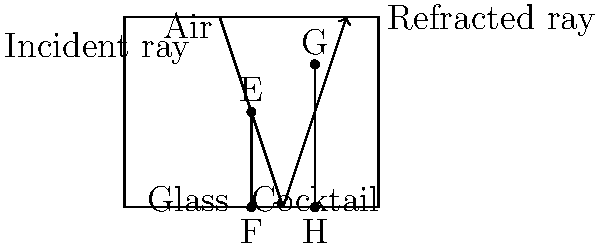As an event promoter planning a physics-themed cocktail party, you want to create an engaging display showcasing light refraction through different cocktail glasses. If light enters a martini glass filled with a cocktail at an angle of 45° to the normal, and the refractive index of the cocktail is 1.36, what is the angle of refraction inside the cocktail? Assume the refractive index of air is 1.00. To solve this problem, we'll use Snell's law, which describes the relationship between the angles of incidence and refraction for light passing through different media:

1) Snell's law states: $n_1 \sin(\theta_1) = n_2 \sin(\theta_2)$

   Where:
   - $n_1$ is the refractive index of the first medium (air)
   - $n_2$ is the refractive index of the second medium (cocktail)
   - $\theta_1$ is the angle of incidence
   - $\theta_2$ is the angle of refraction

2) We're given:
   - $n_1 = 1.00$ (air)
   - $n_2 = 1.36$ (cocktail)
   - $\theta_1 = 45°$

3) Substituting these values into Snell's law:

   $1.00 \sin(45°) = 1.36 \sin(\theta_2)$

4) Simplify:
   $\sin(45°) = 1.36 \sin(\theta_2)$

5) Solve for $\theta_2$:
   $\sin(\theta_2) = \frac{\sin(45°)}{1.36}$

6) Take the inverse sine (arcsin) of both sides:
   $\theta_2 = \arcsin(\frac{\sin(45°)}{1.36})$

7) Calculate:
   $\theta_2 \approx 31.3°$

Therefore, the angle of refraction inside the cocktail is approximately 31.3°.
Answer: 31.3° 